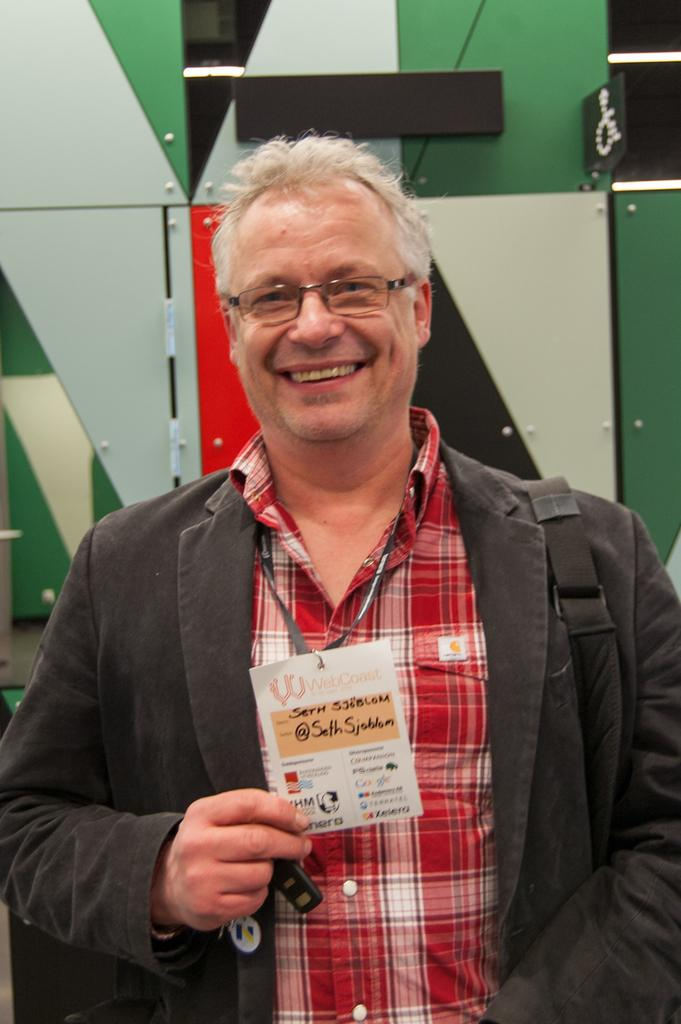What is the main subject of the image? The main subject of the image is a man. What can be observed about the man's appearance? The man is wearing spectacles. What is the man holding in the image? The man is holding a card. What is the man's facial expression? The man is smiling. What can be seen in the background of the image? There is a wall in the background of the image. What type of loaf is the man holding in the image? There is no loaf present in the image; the man is holding a card. How many chickens can be seen in the image? There are no chickens present in the image. 